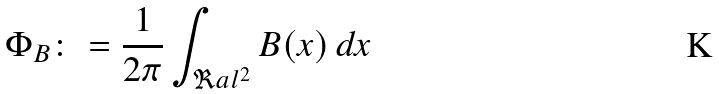Convert formula to latex. <formula><loc_0><loc_0><loc_500><loc_500>\Phi _ { B } \colon = \frac { 1 } { 2 \pi } \int _ { \Re a l ^ { 2 } } B ( x ) \, d x</formula> 